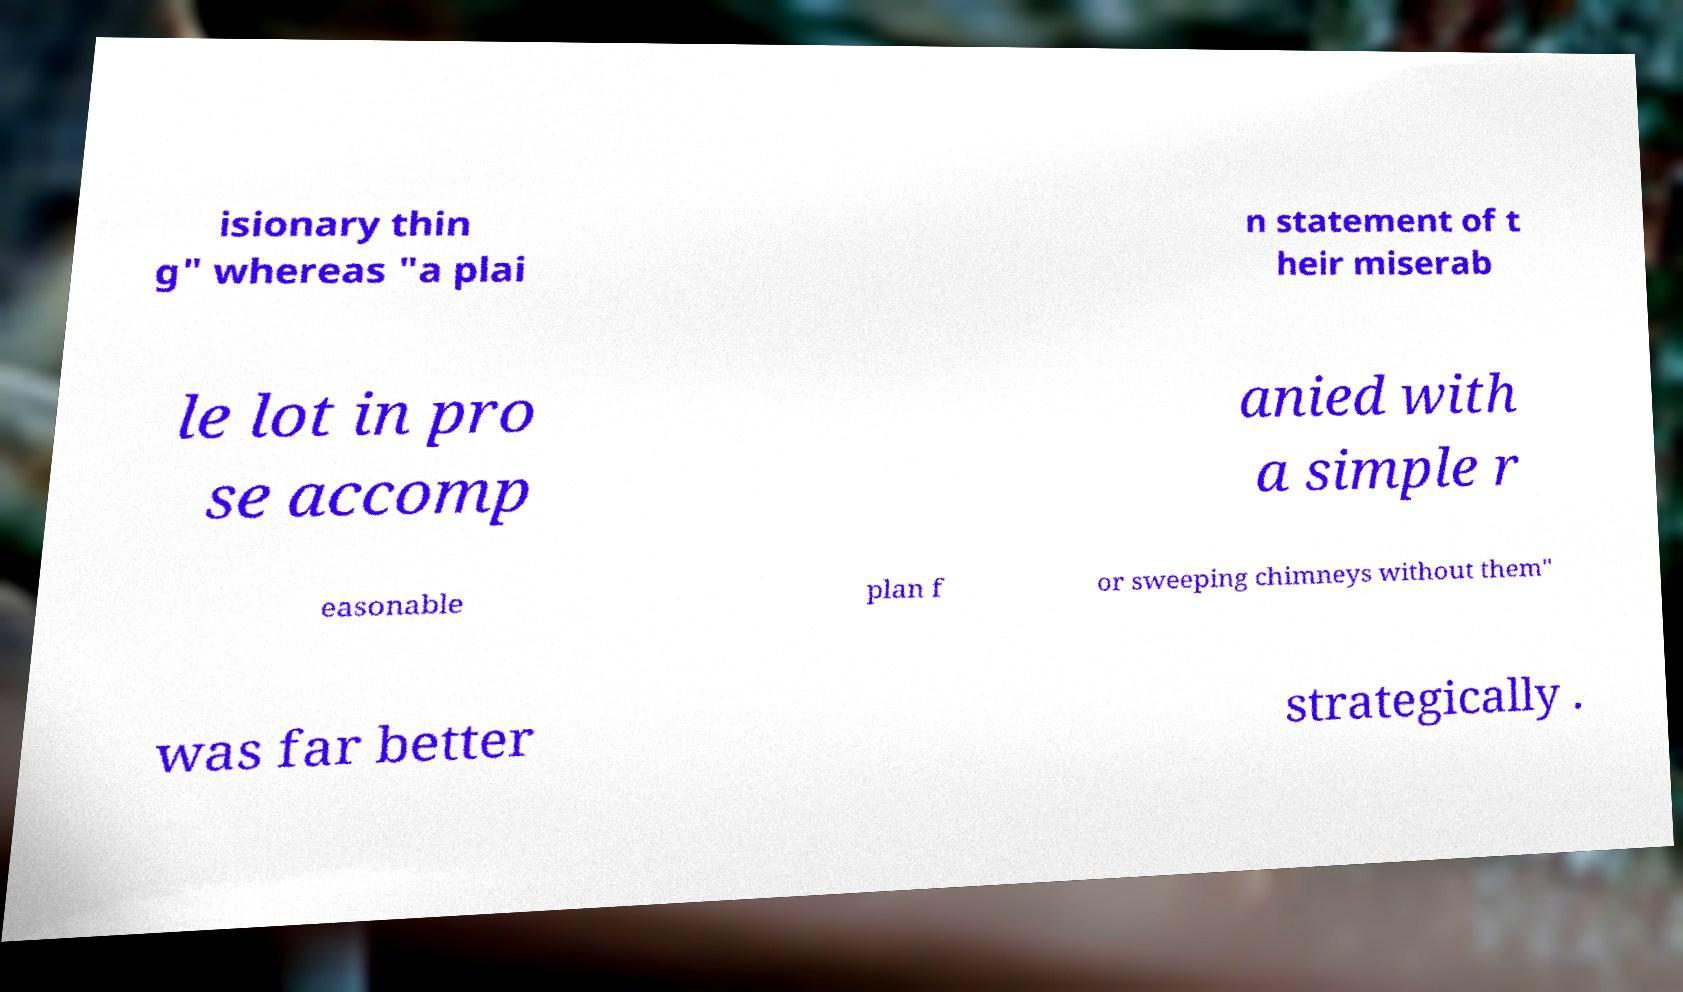Please read and relay the text visible in this image. What does it say? isionary thin g" whereas "a plai n statement of t heir miserab le lot in pro se accomp anied with a simple r easonable plan f or sweeping chimneys without them" was far better strategically . 